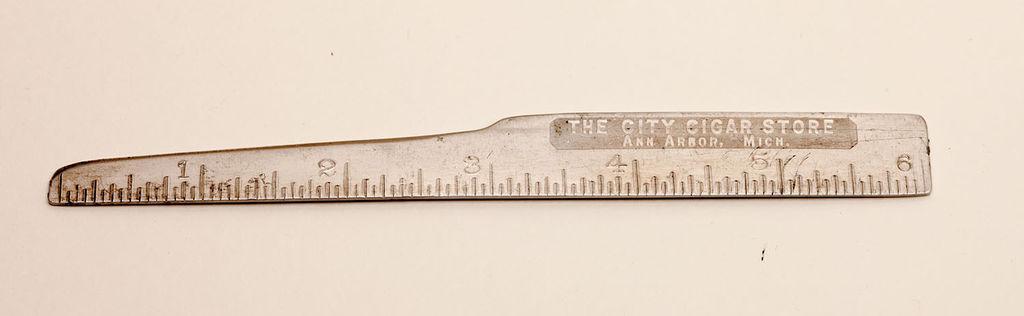In one or two sentences, can you explain what this image depicts? In this image, we can see a scale on the white background. 